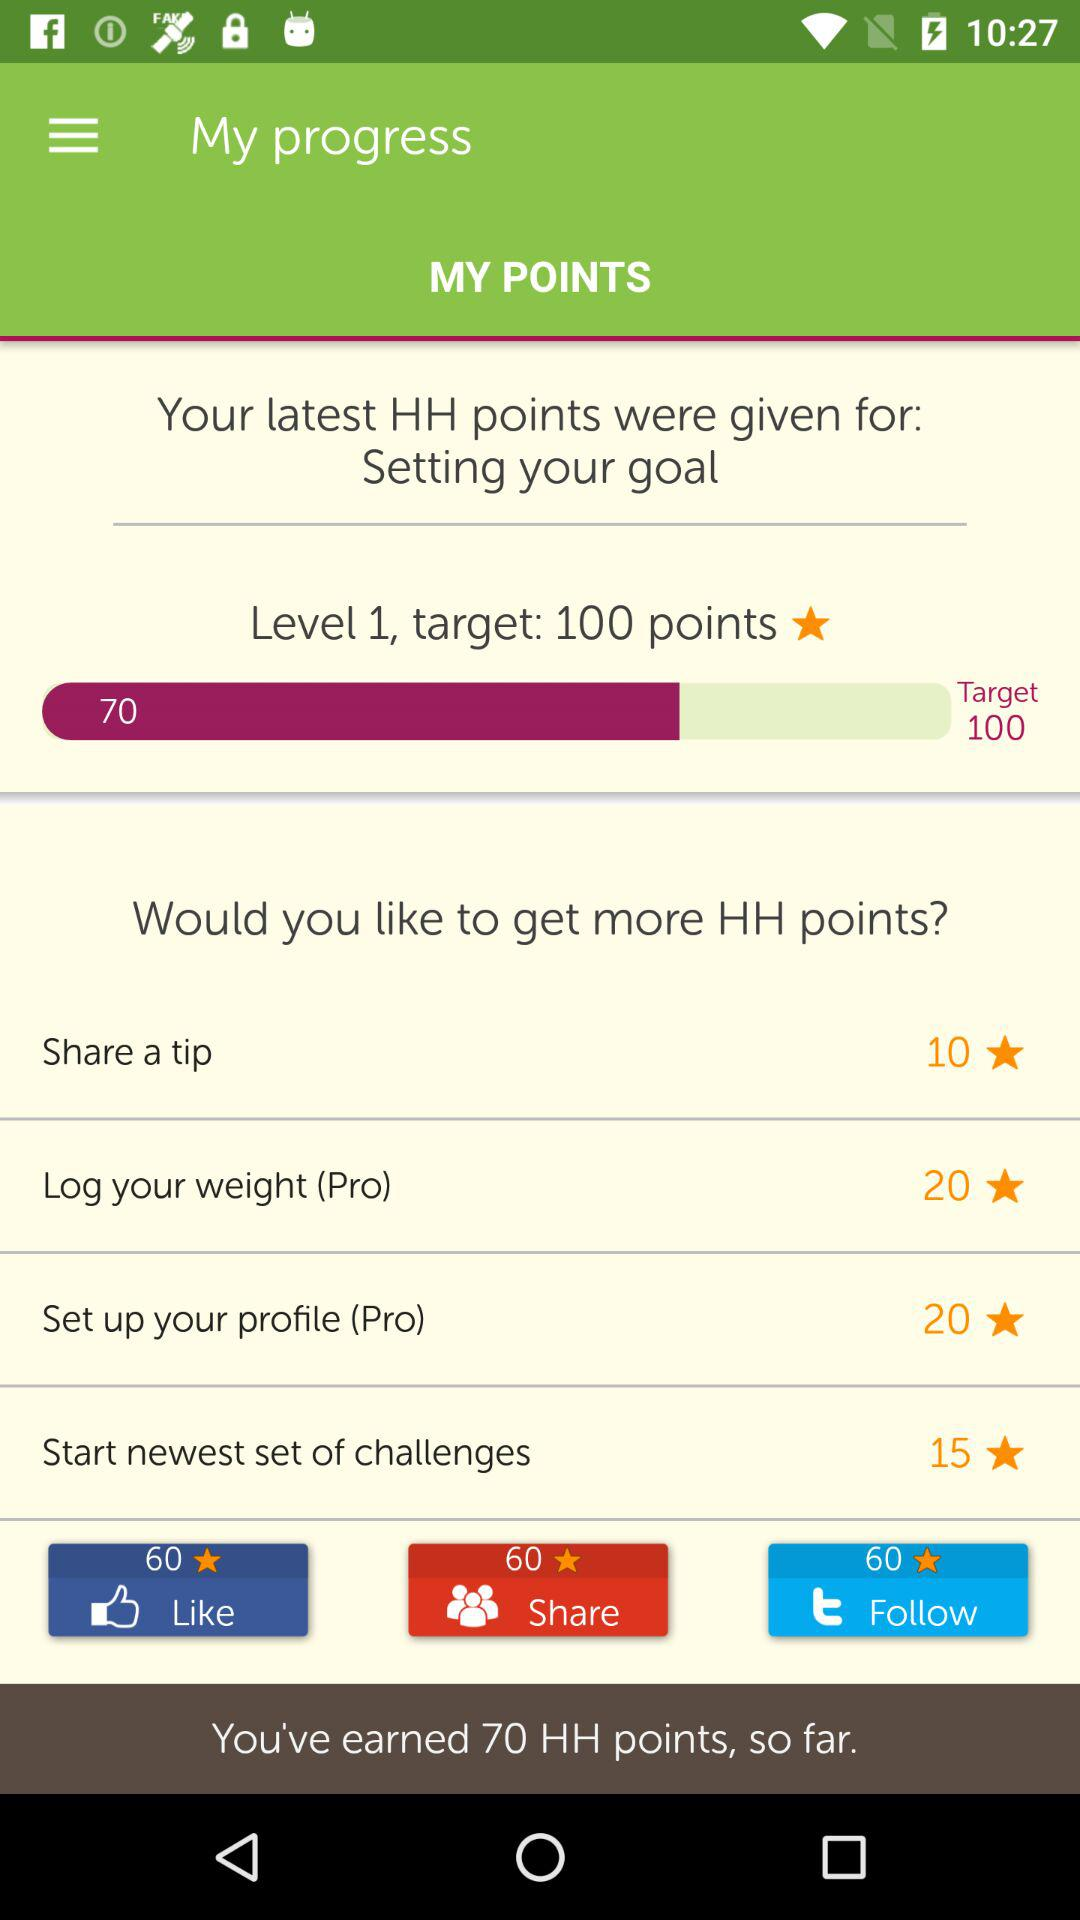How many points can be earned by sharing a tip? The number of points that can be earned by sharing a tip is 10. 